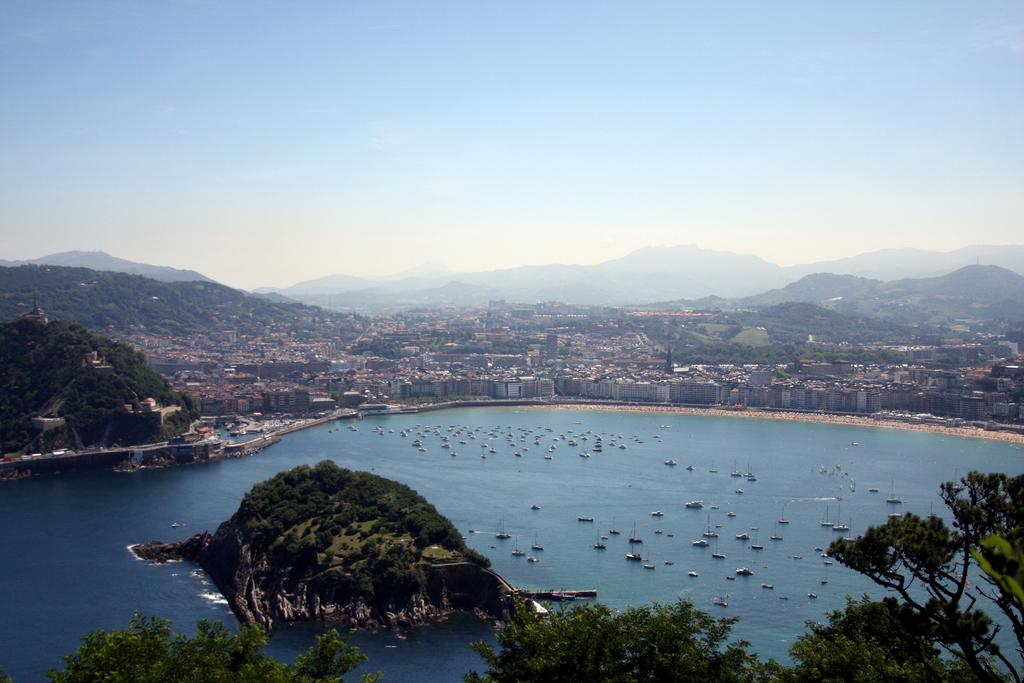What is located at the center of the image? There are ships in the water at the center of the image. What can be seen in the background of the image? There are trees, buildings, mountains, and the sky visible in the background of the image. What type of pipe is being used by the governor in the image? There is no governor or pipe present in the image. 